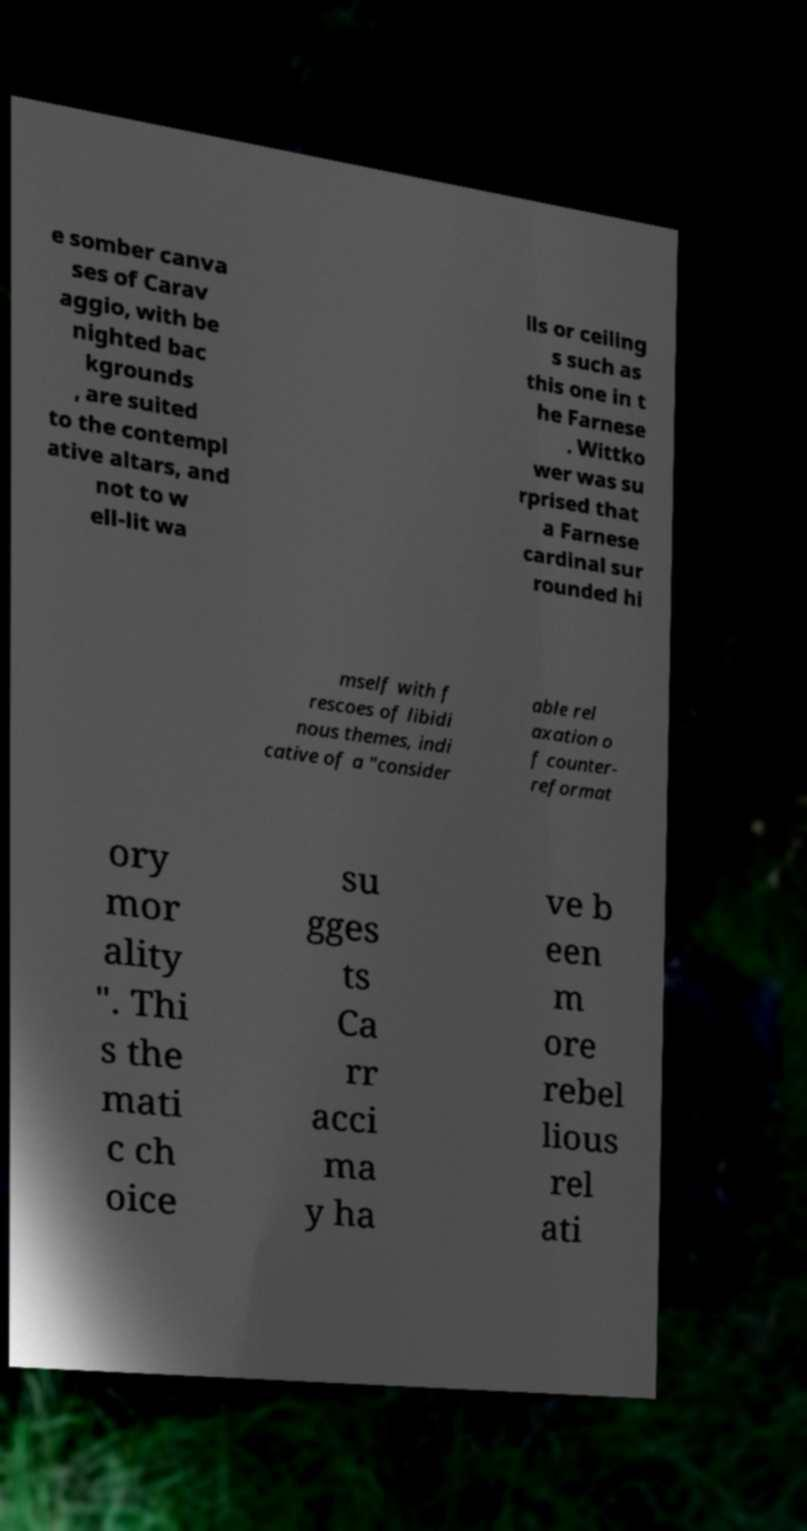There's text embedded in this image that I need extracted. Can you transcribe it verbatim? e somber canva ses of Carav aggio, with be nighted bac kgrounds , are suited to the contempl ative altars, and not to w ell-lit wa lls or ceiling s such as this one in t he Farnese . Wittko wer was su rprised that a Farnese cardinal sur rounded hi mself with f rescoes of libidi nous themes, indi cative of a "consider able rel axation o f counter- reformat ory mor ality ". Thi s the mati c ch oice su gges ts Ca rr acci ma y ha ve b een m ore rebel lious rel ati 